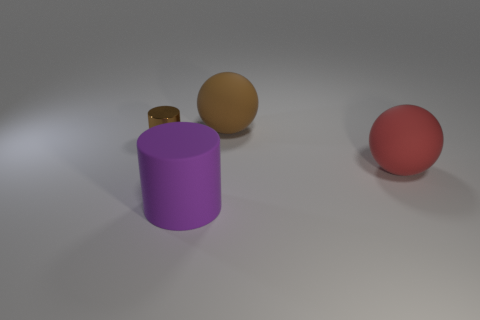There is a large ball that is behind the small metallic object; is it the same color as the small shiny cylinder?
Provide a succinct answer. Yes. Is there anything else that has the same color as the metallic cylinder?
Provide a short and direct response. Yes. Do the cylinder that is on the left side of the big purple matte cylinder and the big rubber ball that is behind the small thing have the same color?
Your answer should be very brief. Yes. Are there more objects that are behind the large purple matte cylinder than purple rubber things behind the tiny brown shiny thing?
Your answer should be compact. Yes. What is the large cylinder made of?
Your response must be concise. Rubber. The large purple object that is to the right of the brown cylinder that is left of the cylinder in front of the brown metal object is what shape?
Make the answer very short. Cylinder. What number of other objects are there of the same material as the red thing?
Keep it short and to the point. 2. Do the sphere in front of the large brown sphere and the big thing that is on the left side of the large brown rubber ball have the same material?
Your response must be concise. Yes. What number of big rubber objects are both in front of the small brown metal object and behind the red ball?
Provide a succinct answer. 0. Are there any small brown shiny objects that have the same shape as the large purple matte object?
Offer a terse response. Yes. 